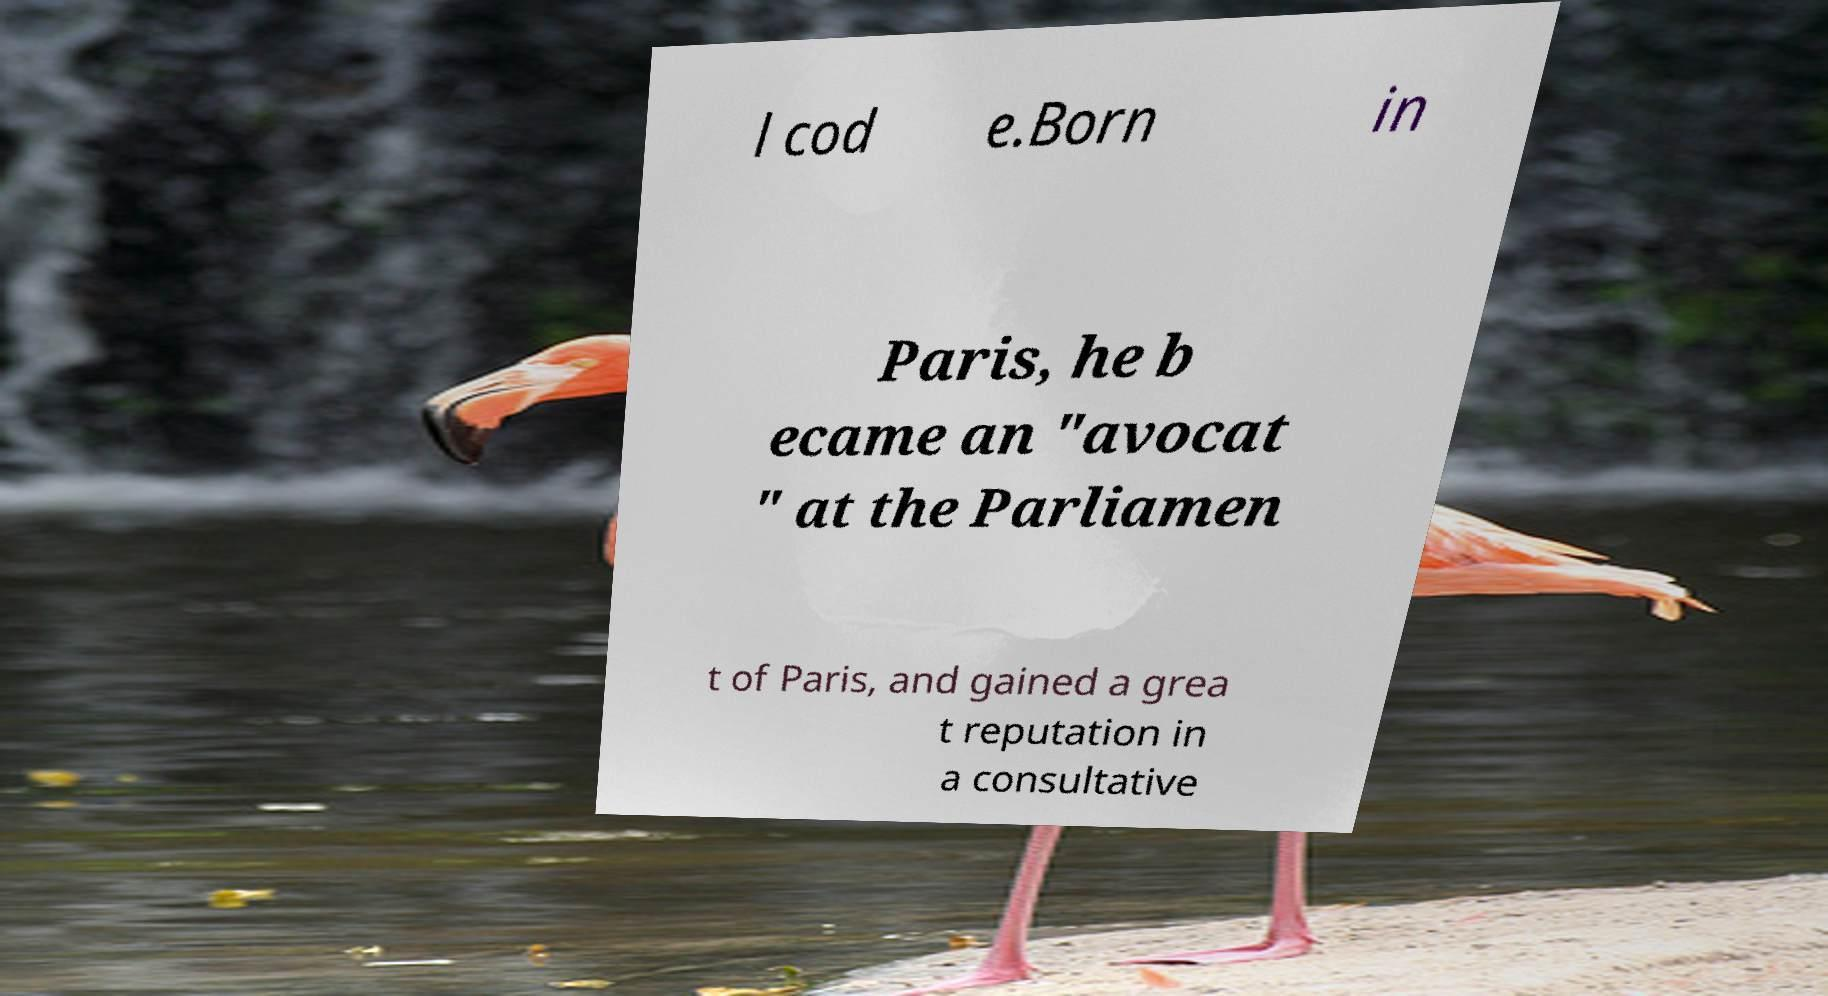There's text embedded in this image that I need extracted. Can you transcribe it verbatim? l cod e.Born in Paris, he b ecame an "avocat " at the Parliamen t of Paris, and gained a grea t reputation in a consultative 